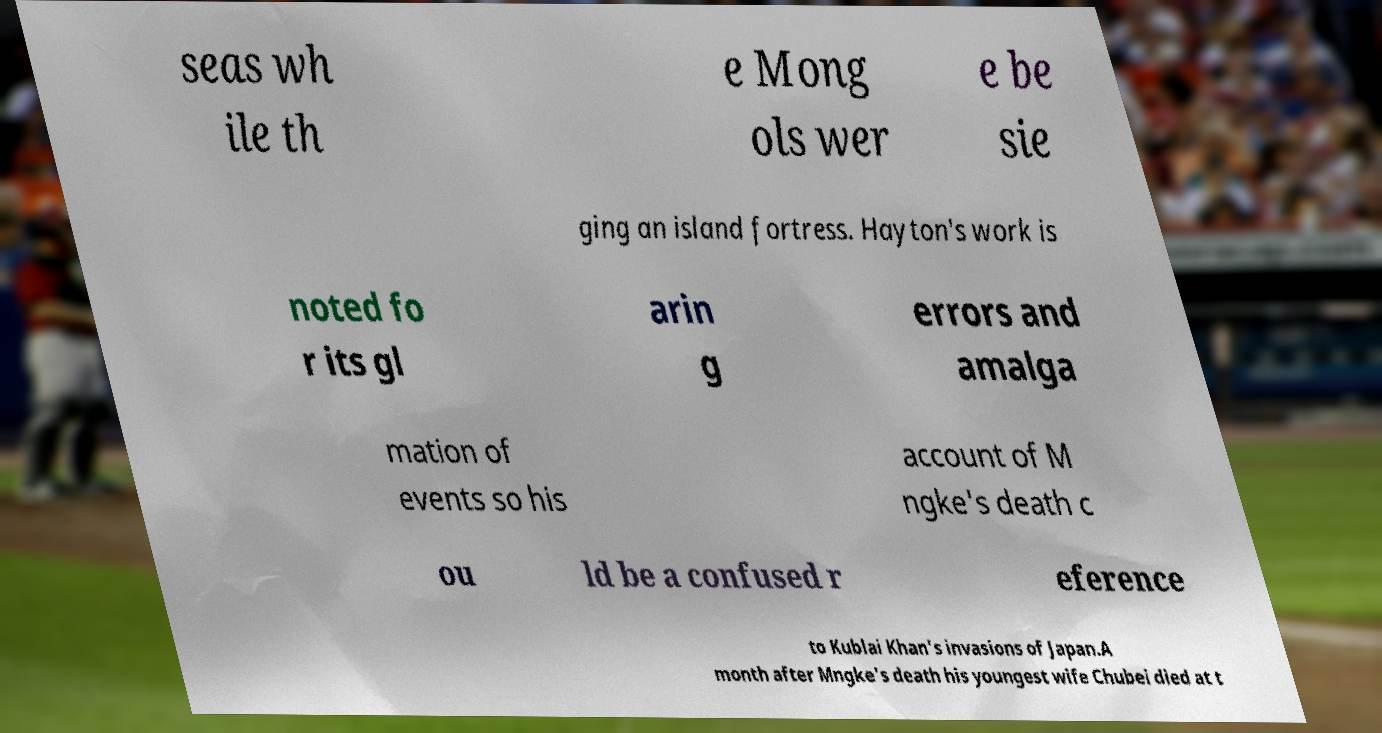Could you extract and type out the text from this image? seas wh ile th e Mong ols wer e be sie ging an island fortress. Hayton's work is noted fo r its gl arin g errors and amalga mation of events so his account of M ngke's death c ou ld be a confused r eference to Kublai Khan's invasions of Japan.A month after Mngke's death his youngest wife Chubei died at t 